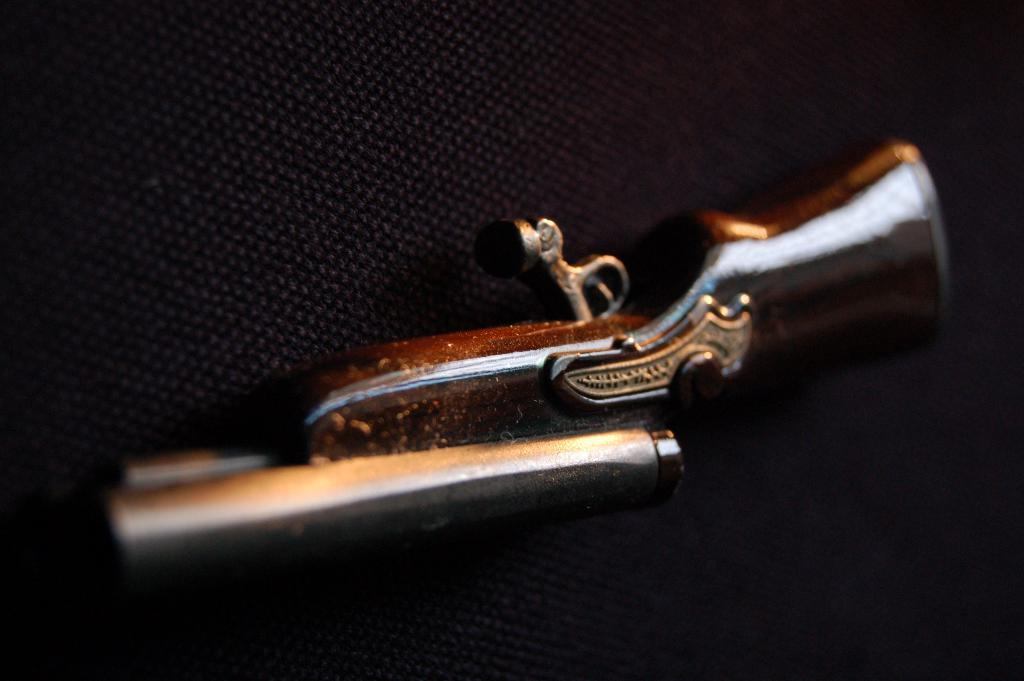What object is present in the image? There is a gun in the image. Where is the gun located? The gun is on a surface. What type of volcano can be seen erupting in the background of the image? There is no volcano present in the image; it only features a gun on a surface. How many dogs are visible in the image? There are no dogs present in the image. 